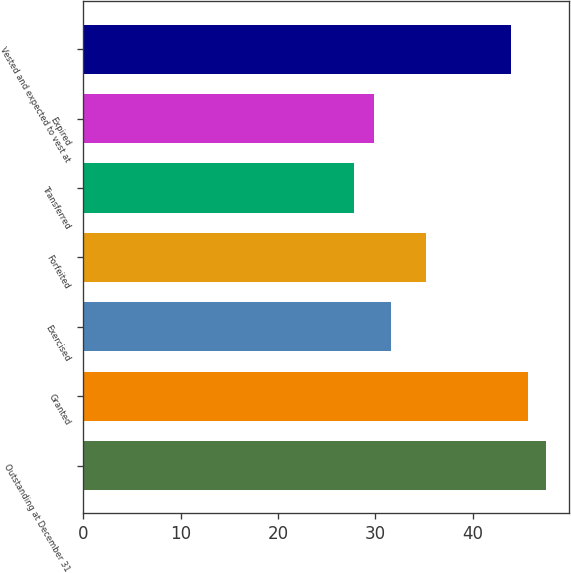Convert chart to OTSL. <chart><loc_0><loc_0><loc_500><loc_500><bar_chart><fcel>Outstanding at December 31<fcel>Granted<fcel>Exercised<fcel>Forfeited<fcel>Transferred<fcel>Expired<fcel>Vested and expected to vest at<nl><fcel>47.51<fcel>45.72<fcel>31.63<fcel>35.21<fcel>27.79<fcel>29.84<fcel>43.93<nl></chart> 